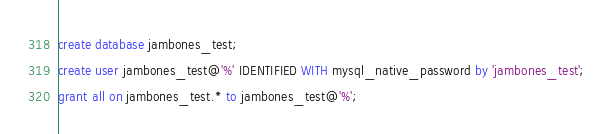Convert code to text. <code><loc_0><loc_0><loc_500><loc_500><_SQL_>create database jambones_test;
create user jambones_test@'%' IDENTIFIED WITH mysql_native_password by 'jambones_test';
grant all on jambones_test.* to jambones_test@'%';
</code> 